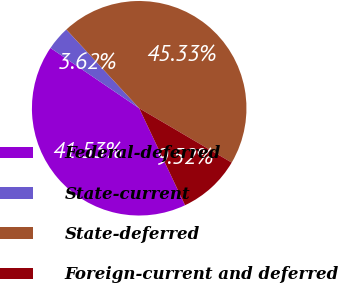Convert chart. <chart><loc_0><loc_0><loc_500><loc_500><pie_chart><fcel>Federal-deferred<fcel>State-current<fcel>State-deferred<fcel>Foreign-current and deferred<nl><fcel>41.53%<fcel>3.62%<fcel>45.33%<fcel>9.52%<nl></chart> 